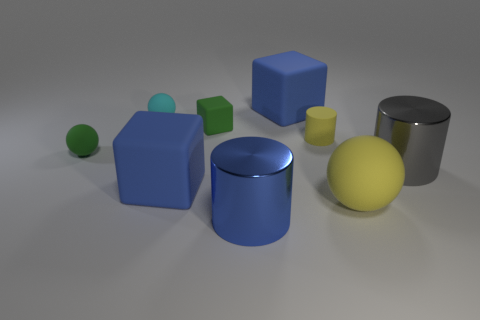Add 1 tiny gray shiny objects. How many objects exist? 10 Subtract all cylinders. How many objects are left? 6 Add 1 cubes. How many cubes exist? 4 Subtract 0 purple cylinders. How many objects are left? 9 Subtract all large blue things. Subtract all big gray shiny objects. How many objects are left? 5 Add 9 small matte cylinders. How many small matte cylinders are left? 10 